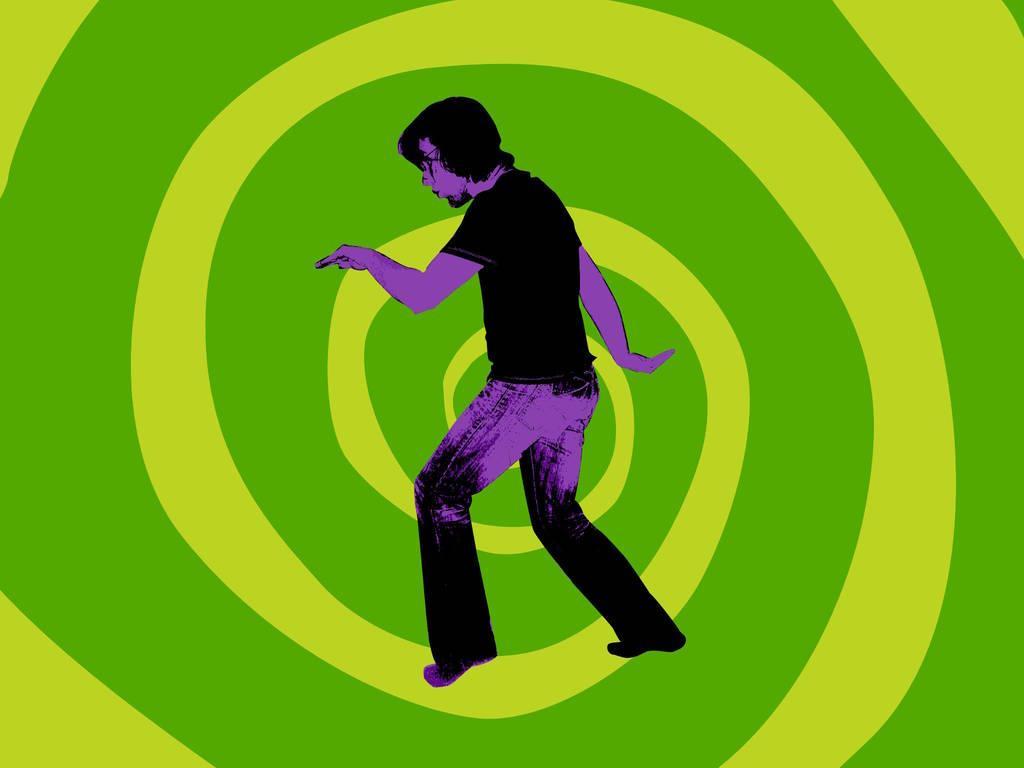Could you give a brief overview of what you see in this image? This is an animated image, we can see a person standing and there is a green background. 